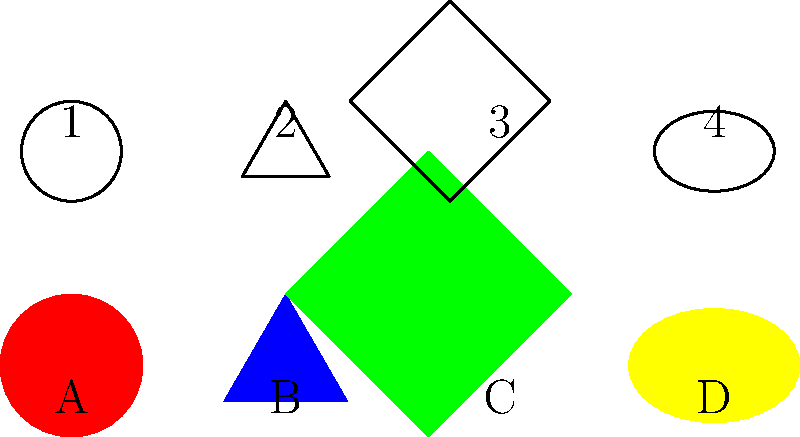Match the colored hamster cages (A, B, C, D) to their corresponding hamster shapes (1, 2, 3, 4). Which color matches with which shape? Let's match the colored cages to the hamster shapes step by step:

1. Cage A is red and circular. The matching shape is number 1, which is also circular.

2. Cage B is blue and triangular. The matching shape is number 2, which is also triangular.

3. Cage C is green and square. The matching shape is number 3, which is also square.

4. Cage D is yellow and oval-shaped (elliptical). The matching shape is number 4, which is also oval-shaped.

Therefore, the correct matches are:
A (red) matches with 1 (circle)
B (blue) matches with 2 (triangle)
C (green) matches with 3 (square)
D (yellow) matches with 4 (oval)
Answer: A-1, B-2, C-3, D-4 